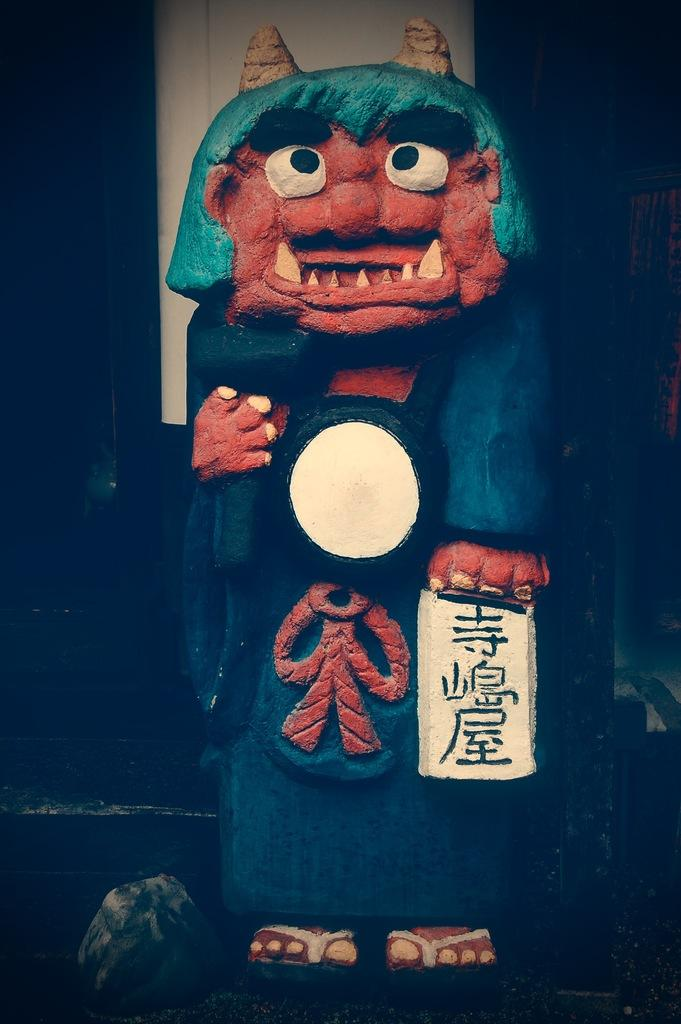What is the main subject of the image? There is a statue in the image. Can you describe the statue? The statue is of a person. How many sheep are visible in the image? There are no sheep present in the image. What type of face can be seen on the statue? The provided facts do not mention any specific details about the face of the statue. 